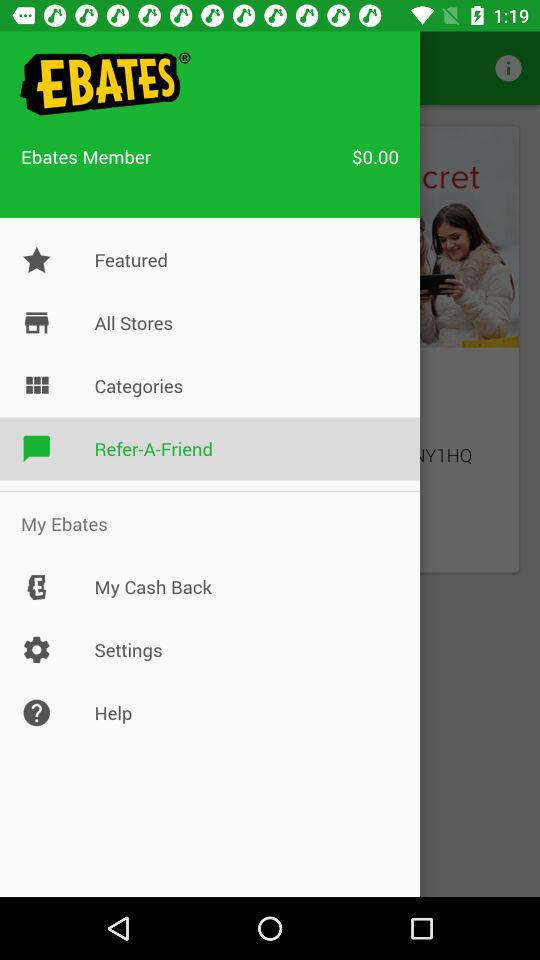Which is the selected option? The selected option is "Refer-A-Friend". 